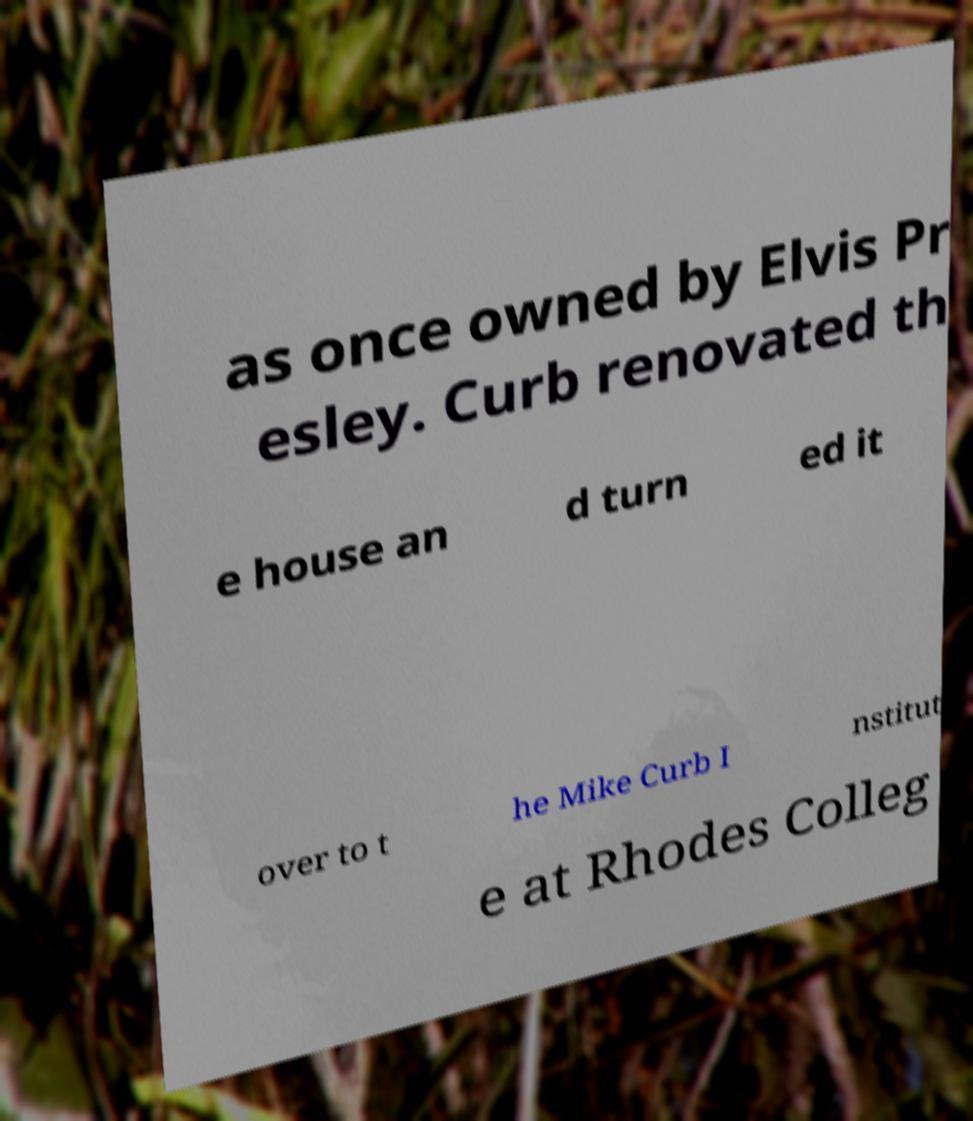Can you accurately transcribe the text from the provided image for me? as once owned by Elvis Pr esley. Curb renovated th e house an d turn ed it over to t he Mike Curb I nstitut e at Rhodes Colleg 